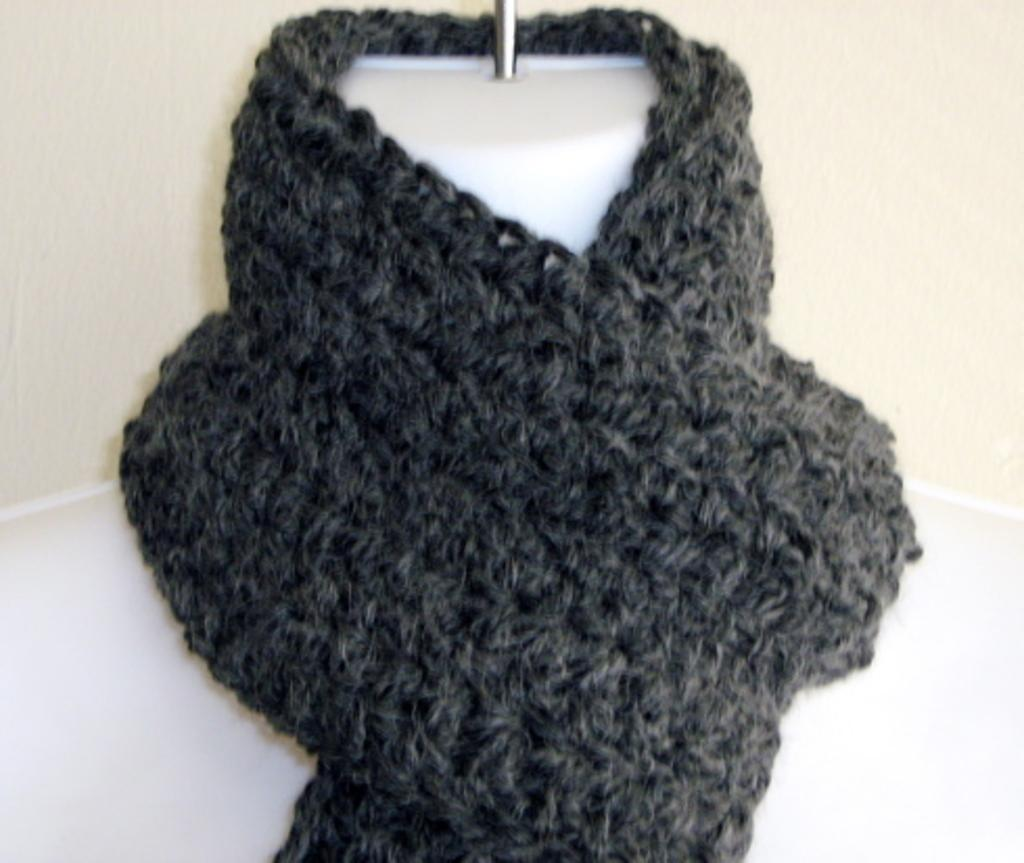What is present in the image related to clothing or accessories? There is a scarf in the image. Can you describe the context in which the scarf is placed? The scarf is placed on a mannequin. What type of veil can be seen covering the jellyfish in the image? There is no veil or jellyfish present in the image; it only features a scarf placed on a mannequin. 